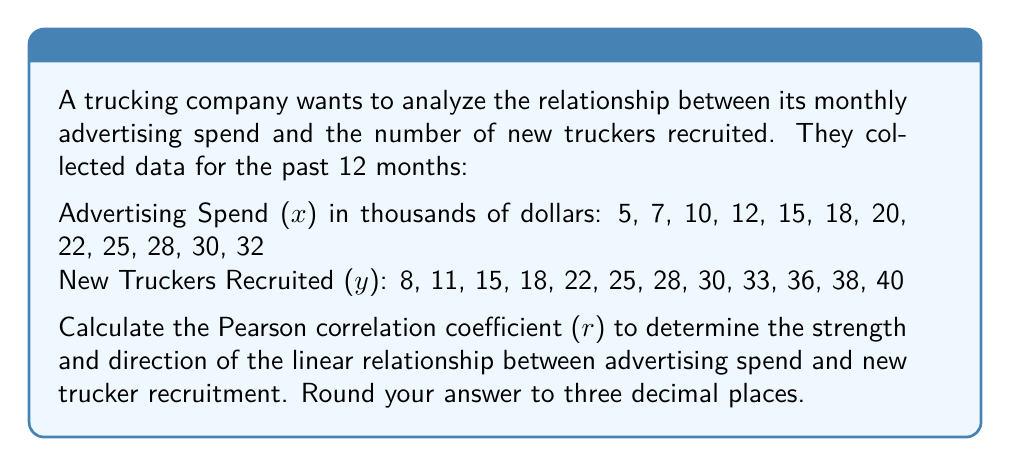Solve this math problem. To calculate the Pearson correlation coefficient (r), we'll use the formula:

$$ r = \frac{n\sum xy - \sum x \sum y}{\sqrt{[n\sum x^2 - (\sum x)^2][n\sum y^2 - (\sum y)^2]}} $$

Where:
n = number of data points
x = advertising spend
y = new truckers recruited

Step 1: Calculate the required sums:
n = 12
$\sum x = 224$
$\sum y = 304$
$\sum xy = 6,224$
$\sum x^2 = 4,930$
$\sum y^2 = 8,630$

Step 2: Calculate $(\sum x)^2$ and $(\sum y)^2$:
$(\sum x)^2 = 224^2 = 50,176$
$(\sum y)^2 = 304^2 = 92,416$

Step 3: Apply the formula:

$$ r = \frac{12(6,224) - (224)(304)}{\sqrt{[12(4,930) - 50,176][12(8,630) - 92,416]}} $$

$$ r = \frac{74,688 - 68,096}{\sqrt{(59,160 - 50,176)(103,560 - 92,416)}} $$

$$ r = \frac{6,592}{\sqrt{(8,984)(11,144)}} $$

$$ r = \frac{6,592}{\sqrt{100,115,296}} $$

$$ r = \frac{6,592}{10,005.76} $$

$$ r \approx 0.659 $$
Answer: The Pearson correlation coefficient (r) is approximately 0.659. 